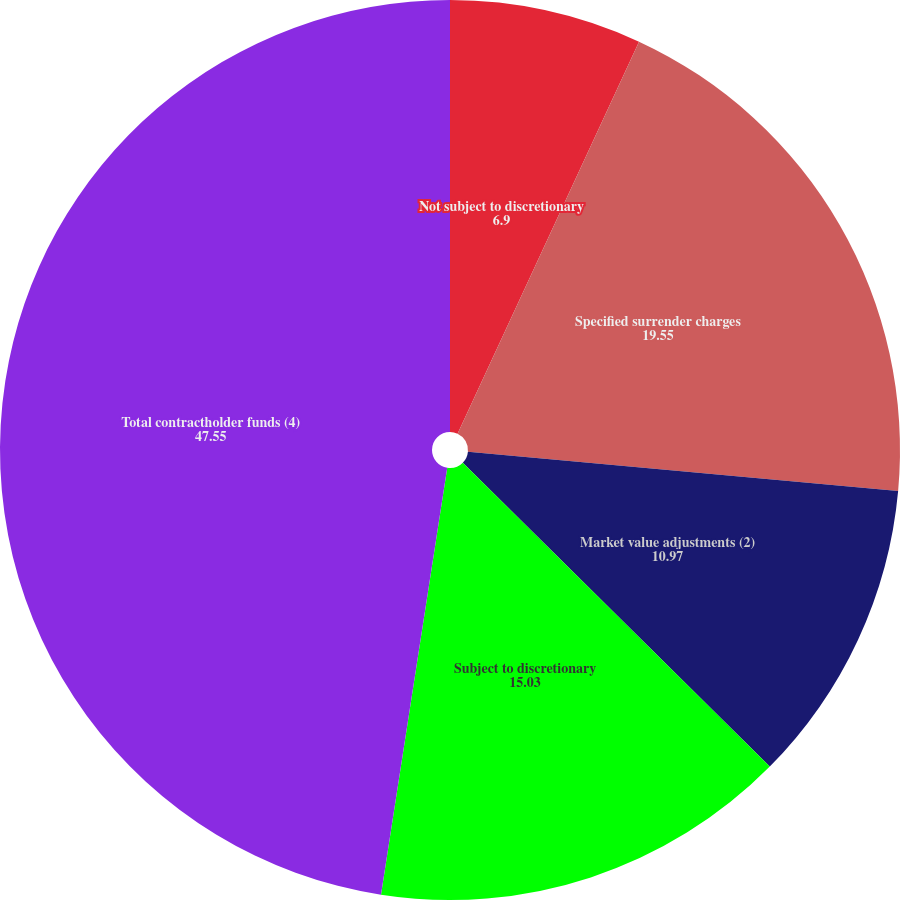Convert chart. <chart><loc_0><loc_0><loc_500><loc_500><pie_chart><fcel>Not subject to discretionary<fcel>Specified surrender charges<fcel>Market value adjustments (2)<fcel>Subject to discretionary<fcel>Total contractholder funds (4)<nl><fcel>6.9%<fcel>19.55%<fcel>10.97%<fcel>15.03%<fcel>47.55%<nl></chart> 